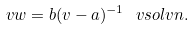<formula> <loc_0><loc_0><loc_500><loc_500>\ v w = b ( \L v - a ) ^ { - 1 } \ v s o l v n .</formula> 